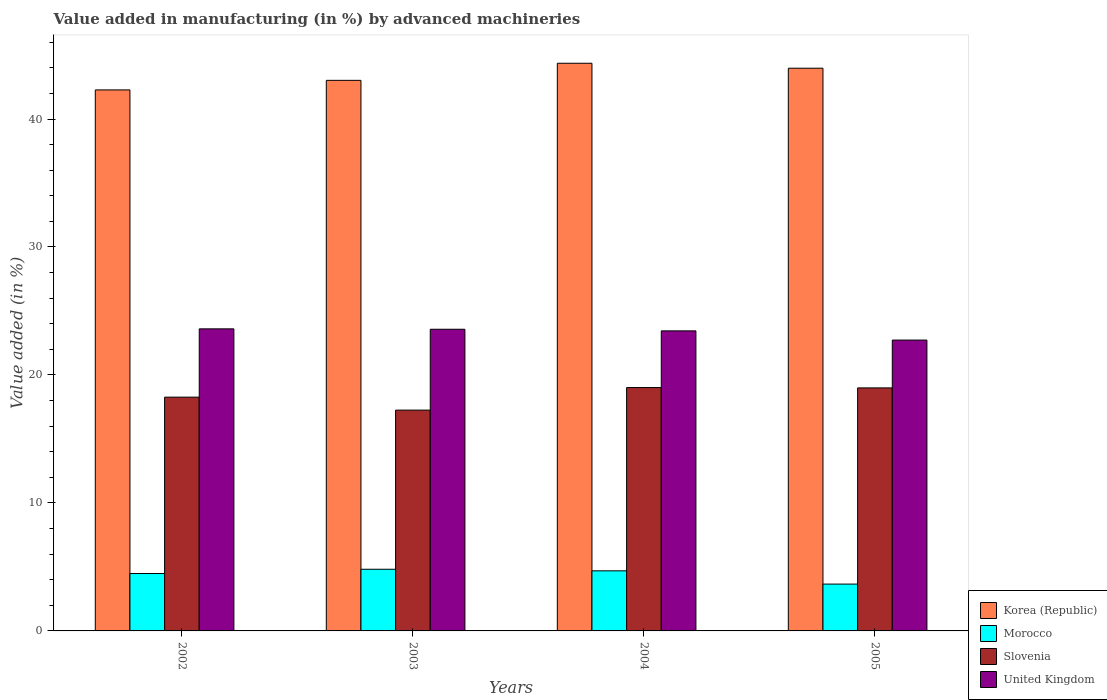How many different coloured bars are there?
Your response must be concise. 4. Are the number of bars per tick equal to the number of legend labels?
Provide a short and direct response. Yes. Are the number of bars on each tick of the X-axis equal?
Offer a terse response. Yes. How many bars are there on the 2nd tick from the left?
Offer a terse response. 4. What is the label of the 3rd group of bars from the left?
Ensure brevity in your answer.  2004. In how many cases, is the number of bars for a given year not equal to the number of legend labels?
Your answer should be very brief. 0. What is the percentage of value added in manufacturing by advanced machineries in United Kingdom in 2003?
Your answer should be compact. 23.57. Across all years, what is the maximum percentage of value added in manufacturing by advanced machineries in Morocco?
Your answer should be compact. 4.82. Across all years, what is the minimum percentage of value added in manufacturing by advanced machineries in Korea (Republic)?
Your answer should be very brief. 42.27. In which year was the percentage of value added in manufacturing by advanced machineries in United Kingdom maximum?
Give a very brief answer. 2002. What is the total percentage of value added in manufacturing by advanced machineries in Morocco in the graph?
Your answer should be compact. 17.66. What is the difference between the percentage of value added in manufacturing by advanced machineries in Slovenia in 2002 and that in 2004?
Keep it short and to the point. -0.75. What is the difference between the percentage of value added in manufacturing by advanced machineries in Morocco in 2002 and the percentage of value added in manufacturing by advanced machineries in United Kingdom in 2004?
Your answer should be compact. -18.96. What is the average percentage of value added in manufacturing by advanced machineries in Korea (Republic) per year?
Your answer should be very brief. 43.41. In the year 2002, what is the difference between the percentage of value added in manufacturing by advanced machineries in Korea (Republic) and percentage of value added in manufacturing by advanced machineries in Slovenia?
Offer a terse response. 24.01. In how many years, is the percentage of value added in manufacturing by advanced machineries in Slovenia greater than 38 %?
Ensure brevity in your answer.  0. What is the ratio of the percentage of value added in manufacturing by advanced machineries in United Kingdom in 2003 to that in 2005?
Offer a very short reply. 1.04. Is the percentage of value added in manufacturing by advanced machineries in Morocco in 2002 less than that in 2004?
Provide a short and direct response. Yes. What is the difference between the highest and the second highest percentage of value added in manufacturing by advanced machineries in United Kingdom?
Offer a very short reply. 0.03. What is the difference between the highest and the lowest percentage of value added in manufacturing by advanced machineries in Morocco?
Ensure brevity in your answer.  1.16. In how many years, is the percentage of value added in manufacturing by advanced machineries in Morocco greater than the average percentage of value added in manufacturing by advanced machineries in Morocco taken over all years?
Keep it short and to the point. 3. Is it the case that in every year, the sum of the percentage of value added in manufacturing by advanced machineries in Morocco and percentage of value added in manufacturing by advanced machineries in Slovenia is greater than the sum of percentage of value added in manufacturing by advanced machineries in Korea (Republic) and percentage of value added in manufacturing by advanced machineries in United Kingdom?
Offer a very short reply. No. How many bars are there?
Your answer should be very brief. 16. Are the values on the major ticks of Y-axis written in scientific E-notation?
Provide a succinct answer. No. What is the title of the graph?
Keep it short and to the point. Value added in manufacturing (in %) by advanced machineries. What is the label or title of the Y-axis?
Give a very brief answer. Value added (in %). What is the Value added (in %) of Korea (Republic) in 2002?
Offer a terse response. 42.27. What is the Value added (in %) of Morocco in 2002?
Provide a short and direct response. 4.48. What is the Value added (in %) in Slovenia in 2002?
Give a very brief answer. 18.27. What is the Value added (in %) in United Kingdom in 2002?
Make the answer very short. 23.6. What is the Value added (in %) of Korea (Republic) in 2003?
Offer a very short reply. 43.02. What is the Value added (in %) of Morocco in 2003?
Provide a succinct answer. 4.82. What is the Value added (in %) in Slovenia in 2003?
Provide a short and direct response. 17.25. What is the Value added (in %) in United Kingdom in 2003?
Your response must be concise. 23.57. What is the Value added (in %) of Korea (Republic) in 2004?
Offer a very short reply. 44.36. What is the Value added (in %) in Morocco in 2004?
Provide a succinct answer. 4.69. What is the Value added (in %) in Slovenia in 2004?
Your answer should be compact. 19.02. What is the Value added (in %) of United Kingdom in 2004?
Keep it short and to the point. 23.45. What is the Value added (in %) in Korea (Republic) in 2005?
Your answer should be compact. 43.97. What is the Value added (in %) of Morocco in 2005?
Offer a terse response. 3.66. What is the Value added (in %) of Slovenia in 2005?
Keep it short and to the point. 18.99. What is the Value added (in %) in United Kingdom in 2005?
Ensure brevity in your answer.  22.73. Across all years, what is the maximum Value added (in %) of Korea (Republic)?
Provide a short and direct response. 44.36. Across all years, what is the maximum Value added (in %) of Morocco?
Give a very brief answer. 4.82. Across all years, what is the maximum Value added (in %) of Slovenia?
Keep it short and to the point. 19.02. Across all years, what is the maximum Value added (in %) of United Kingdom?
Your answer should be compact. 23.6. Across all years, what is the minimum Value added (in %) in Korea (Republic)?
Offer a very short reply. 42.27. Across all years, what is the minimum Value added (in %) of Morocco?
Give a very brief answer. 3.66. Across all years, what is the minimum Value added (in %) in Slovenia?
Offer a very short reply. 17.25. Across all years, what is the minimum Value added (in %) in United Kingdom?
Give a very brief answer. 22.73. What is the total Value added (in %) of Korea (Republic) in the graph?
Offer a very short reply. 173.62. What is the total Value added (in %) of Morocco in the graph?
Ensure brevity in your answer.  17.66. What is the total Value added (in %) of Slovenia in the graph?
Your response must be concise. 73.53. What is the total Value added (in %) of United Kingdom in the graph?
Ensure brevity in your answer.  93.35. What is the difference between the Value added (in %) of Korea (Republic) in 2002 and that in 2003?
Make the answer very short. -0.75. What is the difference between the Value added (in %) of Morocco in 2002 and that in 2003?
Offer a terse response. -0.33. What is the difference between the Value added (in %) in Slovenia in 2002 and that in 2003?
Offer a very short reply. 1.01. What is the difference between the Value added (in %) of United Kingdom in 2002 and that in 2003?
Ensure brevity in your answer.  0.03. What is the difference between the Value added (in %) of Korea (Republic) in 2002 and that in 2004?
Ensure brevity in your answer.  -2.08. What is the difference between the Value added (in %) of Morocco in 2002 and that in 2004?
Your answer should be very brief. -0.21. What is the difference between the Value added (in %) in Slovenia in 2002 and that in 2004?
Your response must be concise. -0.75. What is the difference between the Value added (in %) of United Kingdom in 2002 and that in 2004?
Provide a short and direct response. 0.16. What is the difference between the Value added (in %) in Korea (Republic) in 2002 and that in 2005?
Provide a succinct answer. -1.7. What is the difference between the Value added (in %) of Morocco in 2002 and that in 2005?
Your answer should be compact. 0.82. What is the difference between the Value added (in %) of Slovenia in 2002 and that in 2005?
Your answer should be compact. -0.72. What is the difference between the Value added (in %) in United Kingdom in 2002 and that in 2005?
Ensure brevity in your answer.  0.88. What is the difference between the Value added (in %) in Korea (Republic) in 2003 and that in 2004?
Offer a very short reply. -1.34. What is the difference between the Value added (in %) of Morocco in 2003 and that in 2004?
Keep it short and to the point. 0.12. What is the difference between the Value added (in %) in Slovenia in 2003 and that in 2004?
Your answer should be compact. -1.76. What is the difference between the Value added (in %) in United Kingdom in 2003 and that in 2004?
Your response must be concise. 0.13. What is the difference between the Value added (in %) of Korea (Republic) in 2003 and that in 2005?
Keep it short and to the point. -0.95. What is the difference between the Value added (in %) of Morocco in 2003 and that in 2005?
Offer a very short reply. 1.16. What is the difference between the Value added (in %) of Slovenia in 2003 and that in 2005?
Give a very brief answer. -1.74. What is the difference between the Value added (in %) in United Kingdom in 2003 and that in 2005?
Your answer should be very brief. 0.85. What is the difference between the Value added (in %) in Korea (Republic) in 2004 and that in 2005?
Your answer should be compact. 0.39. What is the difference between the Value added (in %) of Morocco in 2004 and that in 2005?
Provide a succinct answer. 1.03. What is the difference between the Value added (in %) of Slovenia in 2004 and that in 2005?
Your answer should be compact. 0.03. What is the difference between the Value added (in %) of United Kingdom in 2004 and that in 2005?
Give a very brief answer. 0.72. What is the difference between the Value added (in %) in Korea (Republic) in 2002 and the Value added (in %) in Morocco in 2003?
Make the answer very short. 37.46. What is the difference between the Value added (in %) of Korea (Republic) in 2002 and the Value added (in %) of Slovenia in 2003?
Offer a very short reply. 25.02. What is the difference between the Value added (in %) in Korea (Republic) in 2002 and the Value added (in %) in United Kingdom in 2003?
Provide a succinct answer. 18.7. What is the difference between the Value added (in %) in Morocco in 2002 and the Value added (in %) in Slovenia in 2003?
Offer a very short reply. -12.77. What is the difference between the Value added (in %) in Morocco in 2002 and the Value added (in %) in United Kingdom in 2003?
Ensure brevity in your answer.  -19.09. What is the difference between the Value added (in %) in Slovenia in 2002 and the Value added (in %) in United Kingdom in 2003?
Offer a very short reply. -5.31. What is the difference between the Value added (in %) in Korea (Republic) in 2002 and the Value added (in %) in Morocco in 2004?
Provide a short and direct response. 37.58. What is the difference between the Value added (in %) in Korea (Republic) in 2002 and the Value added (in %) in Slovenia in 2004?
Make the answer very short. 23.26. What is the difference between the Value added (in %) of Korea (Republic) in 2002 and the Value added (in %) of United Kingdom in 2004?
Your answer should be compact. 18.83. What is the difference between the Value added (in %) in Morocco in 2002 and the Value added (in %) in Slovenia in 2004?
Give a very brief answer. -14.53. What is the difference between the Value added (in %) of Morocco in 2002 and the Value added (in %) of United Kingdom in 2004?
Your answer should be compact. -18.96. What is the difference between the Value added (in %) in Slovenia in 2002 and the Value added (in %) in United Kingdom in 2004?
Your answer should be compact. -5.18. What is the difference between the Value added (in %) in Korea (Republic) in 2002 and the Value added (in %) in Morocco in 2005?
Provide a succinct answer. 38.61. What is the difference between the Value added (in %) of Korea (Republic) in 2002 and the Value added (in %) of Slovenia in 2005?
Provide a succinct answer. 23.28. What is the difference between the Value added (in %) in Korea (Republic) in 2002 and the Value added (in %) in United Kingdom in 2005?
Provide a succinct answer. 19.55. What is the difference between the Value added (in %) in Morocco in 2002 and the Value added (in %) in Slovenia in 2005?
Keep it short and to the point. -14.51. What is the difference between the Value added (in %) in Morocco in 2002 and the Value added (in %) in United Kingdom in 2005?
Your response must be concise. -18.24. What is the difference between the Value added (in %) in Slovenia in 2002 and the Value added (in %) in United Kingdom in 2005?
Make the answer very short. -4.46. What is the difference between the Value added (in %) in Korea (Republic) in 2003 and the Value added (in %) in Morocco in 2004?
Your response must be concise. 38.33. What is the difference between the Value added (in %) in Korea (Republic) in 2003 and the Value added (in %) in Slovenia in 2004?
Your answer should be compact. 24.01. What is the difference between the Value added (in %) in Korea (Republic) in 2003 and the Value added (in %) in United Kingdom in 2004?
Ensure brevity in your answer.  19.58. What is the difference between the Value added (in %) in Morocco in 2003 and the Value added (in %) in Slovenia in 2004?
Give a very brief answer. -14.2. What is the difference between the Value added (in %) of Morocco in 2003 and the Value added (in %) of United Kingdom in 2004?
Offer a terse response. -18.63. What is the difference between the Value added (in %) in Slovenia in 2003 and the Value added (in %) in United Kingdom in 2004?
Make the answer very short. -6.19. What is the difference between the Value added (in %) in Korea (Republic) in 2003 and the Value added (in %) in Morocco in 2005?
Offer a very short reply. 39.36. What is the difference between the Value added (in %) of Korea (Republic) in 2003 and the Value added (in %) of Slovenia in 2005?
Your answer should be compact. 24.03. What is the difference between the Value added (in %) in Korea (Republic) in 2003 and the Value added (in %) in United Kingdom in 2005?
Keep it short and to the point. 20.3. What is the difference between the Value added (in %) of Morocco in 2003 and the Value added (in %) of Slovenia in 2005?
Your response must be concise. -14.17. What is the difference between the Value added (in %) in Morocco in 2003 and the Value added (in %) in United Kingdom in 2005?
Your response must be concise. -17.91. What is the difference between the Value added (in %) in Slovenia in 2003 and the Value added (in %) in United Kingdom in 2005?
Give a very brief answer. -5.47. What is the difference between the Value added (in %) in Korea (Republic) in 2004 and the Value added (in %) in Morocco in 2005?
Your response must be concise. 40.7. What is the difference between the Value added (in %) of Korea (Republic) in 2004 and the Value added (in %) of Slovenia in 2005?
Offer a terse response. 25.37. What is the difference between the Value added (in %) of Korea (Republic) in 2004 and the Value added (in %) of United Kingdom in 2005?
Keep it short and to the point. 21.63. What is the difference between the Value added (in %) of Morocco in 2004 and the Value added (in %) of Slovenia in 2005?
Offer a very short reply. -14.3. What is the difference between the Value added (in %) in Morocco in 2004 and the Value added (in %) in United Kingdom in 2005?
Provide a short and direct response. -18.03. What is the difference between the Value added (in %) of Slovenia in 2004 and the Value added (in %) of United Kingdom in 2005?
Ensure brevity in your answer.  -3.71. What is the average Value added (in %) of Korea (Republic) per year?
Keep it short and to the point. 43.41. What is the average Value added (in %) of Morocco per year?
Your answer should be very brief. 4.41. What is the average Value added (in %) in Slovenia per year?
Make the answer very short. 18.38. What is the average Value added (in %) in United Kingdom per year?
Ensure brevity in your answer.  23.34. In the year 2002, what is the difference between the Value added (in %) of Korea (Republic) and Value added (in %) of Morocco?
Your answer should be very brief. 37.79. In the year 2002, what is the difference between the Value added (in %) of Korea (Republic) and Value added (in %) of Slovenia?
Provide a short and direct response. 24.01. In the year 2002, what is the difference between the Value added (in %) in Korea (Republic) and Value added (in %) in United Kingdom?
Give a very brief answer. 18.67. In the year 2002, what is the difference between the Value added (in %) in Morocco and Value added (in %) in Slovenia?
Your answer should be compact. -13.78. In the year 2002, what is the difference between the Value added (in %) of Morocco and Value added (in %) of United Kingdom?
Give a very brief answer. -19.12. In the year 2002, what is the difference between the Value added (in %) in Slovenia and Value added (in %) in United Kingdom?
Your answer should be compact. -5.34. In the year 2003, what is the difference between the Value added (in %) of Korea (Republic) and Value added (in %) of Morocco?
Keep it short and to the point. 38.2. In the year 2003, what is the difference between the Value added (in %) in Korea (Republic) and Value added (in %) in Slovenia?
Offer a very short reply. 25.77. In the year 2003, what is the difference between the Value added (in %) of Korea (Republic) and Value added (in %) of United Kingdom?
Ensure brevity in your answer.  19.45. In the year 2003, what is the difference between the Value added (in %) in Morocco and Value added (in %) in Slovenia?
Your answer should be compact. -12.43. In the year 2003, what is the difference between the Value added (in %) in Morocco and Value added (in %) in United Kingdom?
Your answer should be very brief. -18.75. In the year 2003, what is the difference between the Value added (in %) in Slovenia and Value added (in %) in United Kingdom?
Your answer should be very brief. -6.32. In the year 2004, what is the difference between the Value added (in %) of Korea (Republic) and Value added (in %) of Morocco?
Your answer should be very brief. 39.66. In the year 2004, what is the difference between the Value added (in %) of Korea (Republic) and Value added (in %) of Slovenia?
Keep it short and to the point. 25.34. In the year 2004, what is the difference between the Value added (in %) in Korea (Republic) and Value added (in %) in United Kingdom?
Make the answer very short. 20.91. In the year 2004, what is the difference between the Value added (in %) of Morocco and Value added (in %) of Slovenia?
Your answer should be compact. -14.32. In the year 2004, what is the difference between the Value added (in %) of Morocco and Value added (in %) of United Kingdom?
Provide a succinct answer. -18.75. In the year 2004, what is the difference between the Value added (in %) in Slovenia and Value added (in %) in United Kingdom?
Ensure brevity in your answer.  -4.43. In the year 2005, what is the difference between the Value added (in %) of Korea (Republic) and Value added (in %) of Morocco?
Make the answer very short. 40.31. In the year 2005, what is the difference between the Value added (in %) in Korea (Republic) and Value added (in %) in Slovenia?
Offer a very short reply. 24.98. In the year 2005, what is the difference between the Value added (in %) of Korea (Republic) and Value added (in %) of United Kingdom?
Offer a very short reply. 21.24. In the year 2005, what is the difference between the Value added (in %) in Morocco and Value added (in %) in Slovenia?
Ensure brevity in your answer.  -15.33. In the year 2005, what is the difference between the Value added (in %) of Morocco and Value added (in %) of United Kingdom?
Offer a very short reply. -19.07. In the year 2005, what is the difference between the Value added (in %) in Slovenia and Value added (in %) in United Kingdom?
Your answer should be compact. -3.74. What is the ratio of the Value added (in %) of Korea (Republic) in 2002 to that in 2003?
Your response must be concise. 0.98. What is the ratio of the Value added (in %) of Morocco in 2002 to that in 2003?
Your answer should be very brief. 0.93. What is the ratio of the Value added (in %) in Slovenia in 2002 to that in 2003?
Your response must be concise. 1.06. What is the ratio of the Value added (in %) of United Kingdom in 2002 to that in 2003?
Offer a terse response. 1. What is the ratio of the Value added (in %) in Korea (Republic) in 2002 to that in 2004?
Offer a terse response. 0.95. What is the ratio of the Value added (in %) in Morocco in 2002 to that in 2004?
Provide a succinct answer. 0.96. What is the ratio of the Value added (in %) of Slovenia in 2002 to that in 2004?
Your answer should be compact. 0.96. What is the ratio of the Value added (in %) of United Kingdom in 2002 to that in 2004?
Your answer should be very brief. 1.01. What is the ratio of the Value added (in %) in Korea (Republic) in 2002 to that in 2005?
Offer a very short reply. 0.96. What is the ratio of the Value added (in %) in Morocco in 2002 to that in 2005?
Offer a terse response. 1.23. What is the ratio of the Value added (in %) of Slovenia in 2002 to that in 2005?
Provide a short and direct response. 0.96. What is the ratio of the Value added (in %) of United Kingdom in 2002 to that in 2005?
Give a very brief answer. 1.04. What is the ratio of the Value added (in %) in Korea (Republic) in 2003 to that in 2004?
Provide a succinct answer. 0.97. What is the ratio of the Value added (in %) in Morocco in 2003 to that in 2004?
Ensure brevity in your answer.  1.03. What is the ratio of the Value added (in %) of Slovenia in 2003 to that in 2004?
Your answer should be compact. 0.91. What is the ratio of the Value added (in %) of United Kingdom in 2003 to that in 2004?
Offer a very short reply. 1.01. What is the ratio of the Value added (in %) in Korea (Republic) in 2003 to that in 2005?
Provide a short and direct response. 0.98. What is the ratio of the Value added (in %) in Morocco in 2003 to that in 2005?
Make the answer very short. 1.32. What is the ratio of the Value added (in %) in Slovenia in 2003 to that in 2005?
Provide a succinct answer. 0.91. What is the ratio of the Value added (in %) in United Kingdom in 2003 to that in 2005?
Your answer should be compact. 1.04. What is the ratio of the Value added (in %) of Korea (Republic) in 2004 to that in 2005?
Your answer should be compact. 1.01. What is the ratio of the Value added (in %) of Morocco in 2004 to that in 2005?
Ensure brevity in your answer.  1.28. What is the ratio of the Value added (in %) of United Kingdom in 2004 to that in 2005?
Give a very brief answer. 1.03. What is the difference between the highest and the second highest Value added (in %) in Korea (Republic)?
Make the answer very short. 0.39. What is the difference between the highest and the second highest Value added (in %) in Morocco?
Offer a very short reply. 0.12. What is the difference between the highest and the second highest Value added (in %) of Slovenia?
Your answer should be compact. 0.03. What is the difference between the highest and the second highest Value added (in %) of United Kingdom?
Provide a succinct answer. 0.03. What is the difference between the highest and the lowest Value added (in %) in Korea (Republic)?
Give a very brief answer. 2.08. What is the difference between the highest and the lowest Value added (in %) in Morocco?
Offer a terse response. 1.16. What is the difference between the highest and the lowest Value added (in %) in Slovenia?
Offer a terse response. 1.76. What is the difference between the highest and the lowest Value added (in %) in United Kingdom?
Provide a succinct answer. 0.88. 